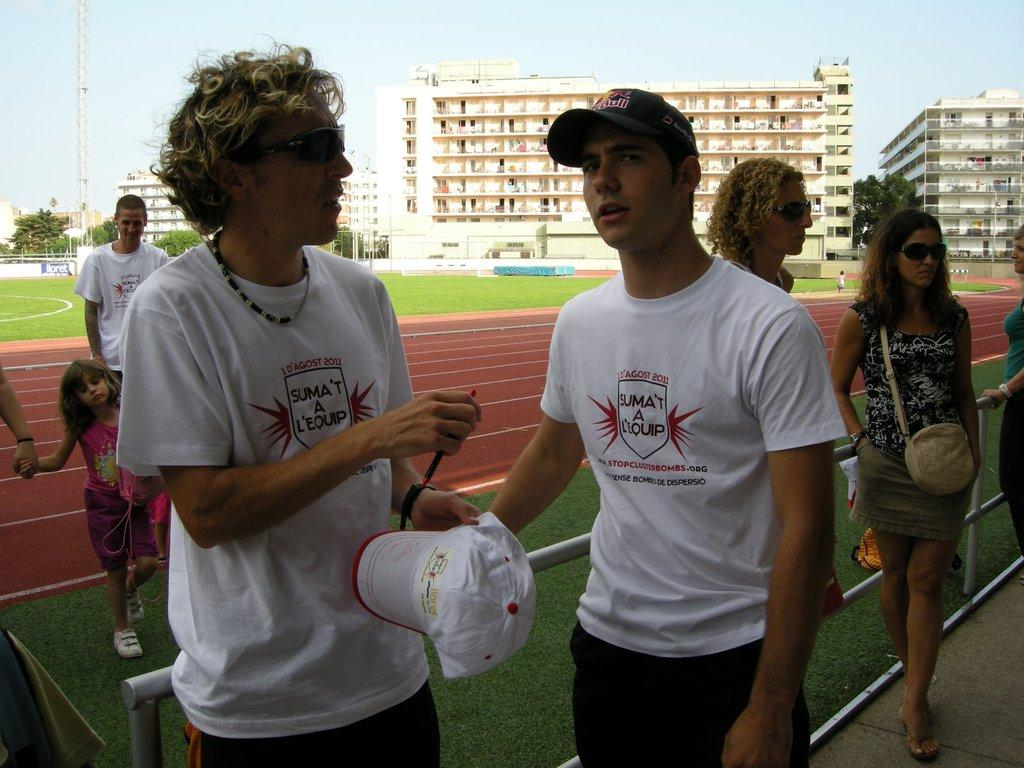What are the people in the image doing? There are groups of people standing in the image. What type of structures can be seen in the image? There are buildings and a tower in the image. What location might the image depict? The image appears to depict a stadium. What type of vegetation is visible in the background? There are trees visible in the background. What part of the natural environment is visible in the image? The sky is visible in the image. What type of insurance policy does the father in the image have? There is no father or insurance policy mentioned in the image. What color is the wristband worn by the person in the image? There is no wristband visible in the image. 